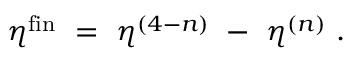Convert formula to latex. <formula><loc_0><loc_0><loc_500><loc_500>\eta ^ { f i n } = \eta ^ { ( 4 - n ) } - \eta ^ { ( n ) } .</formula> 